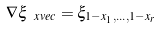Convert formula to latex. <formula><loc_0><loc_0><loc_500><loc_500>\nabla \xi _ { \ x v e c } = \xi _ { 1 - x _ { 1 } , \dots , 1 - x _ { r } }</formula> 